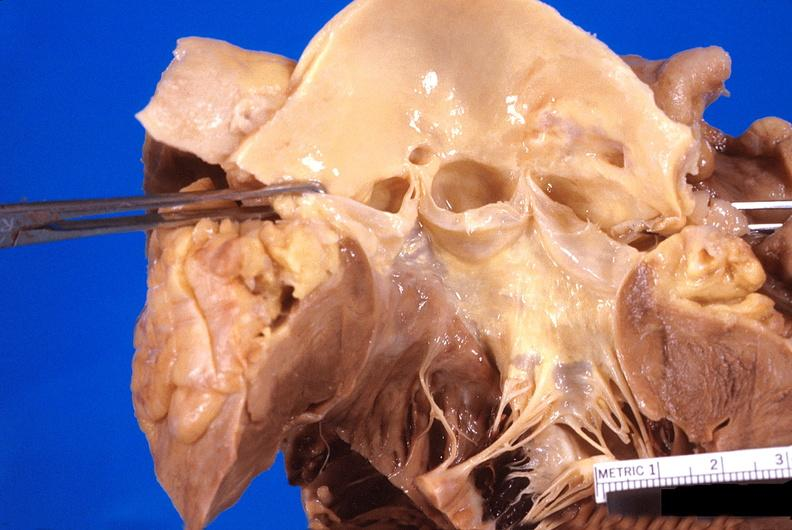what is present?
Answer the question using a single word or phrase. Cardiovascular 